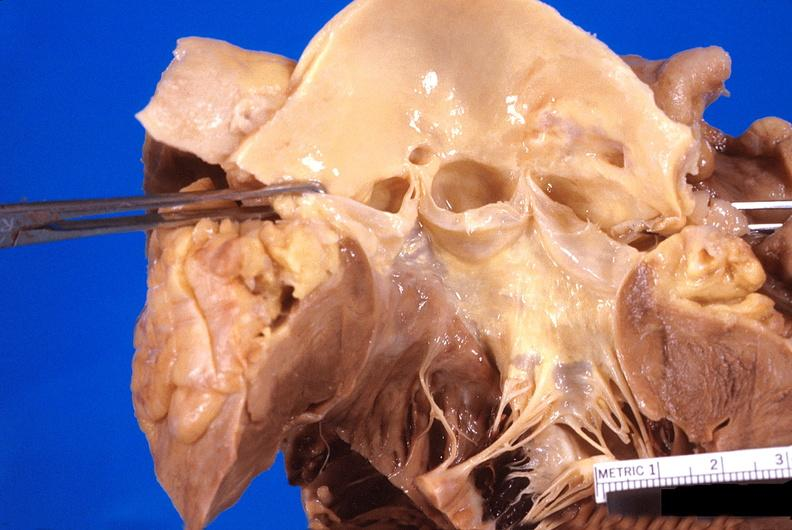what is present?
Answer the question using a single word or phrase. Cardiovascular 